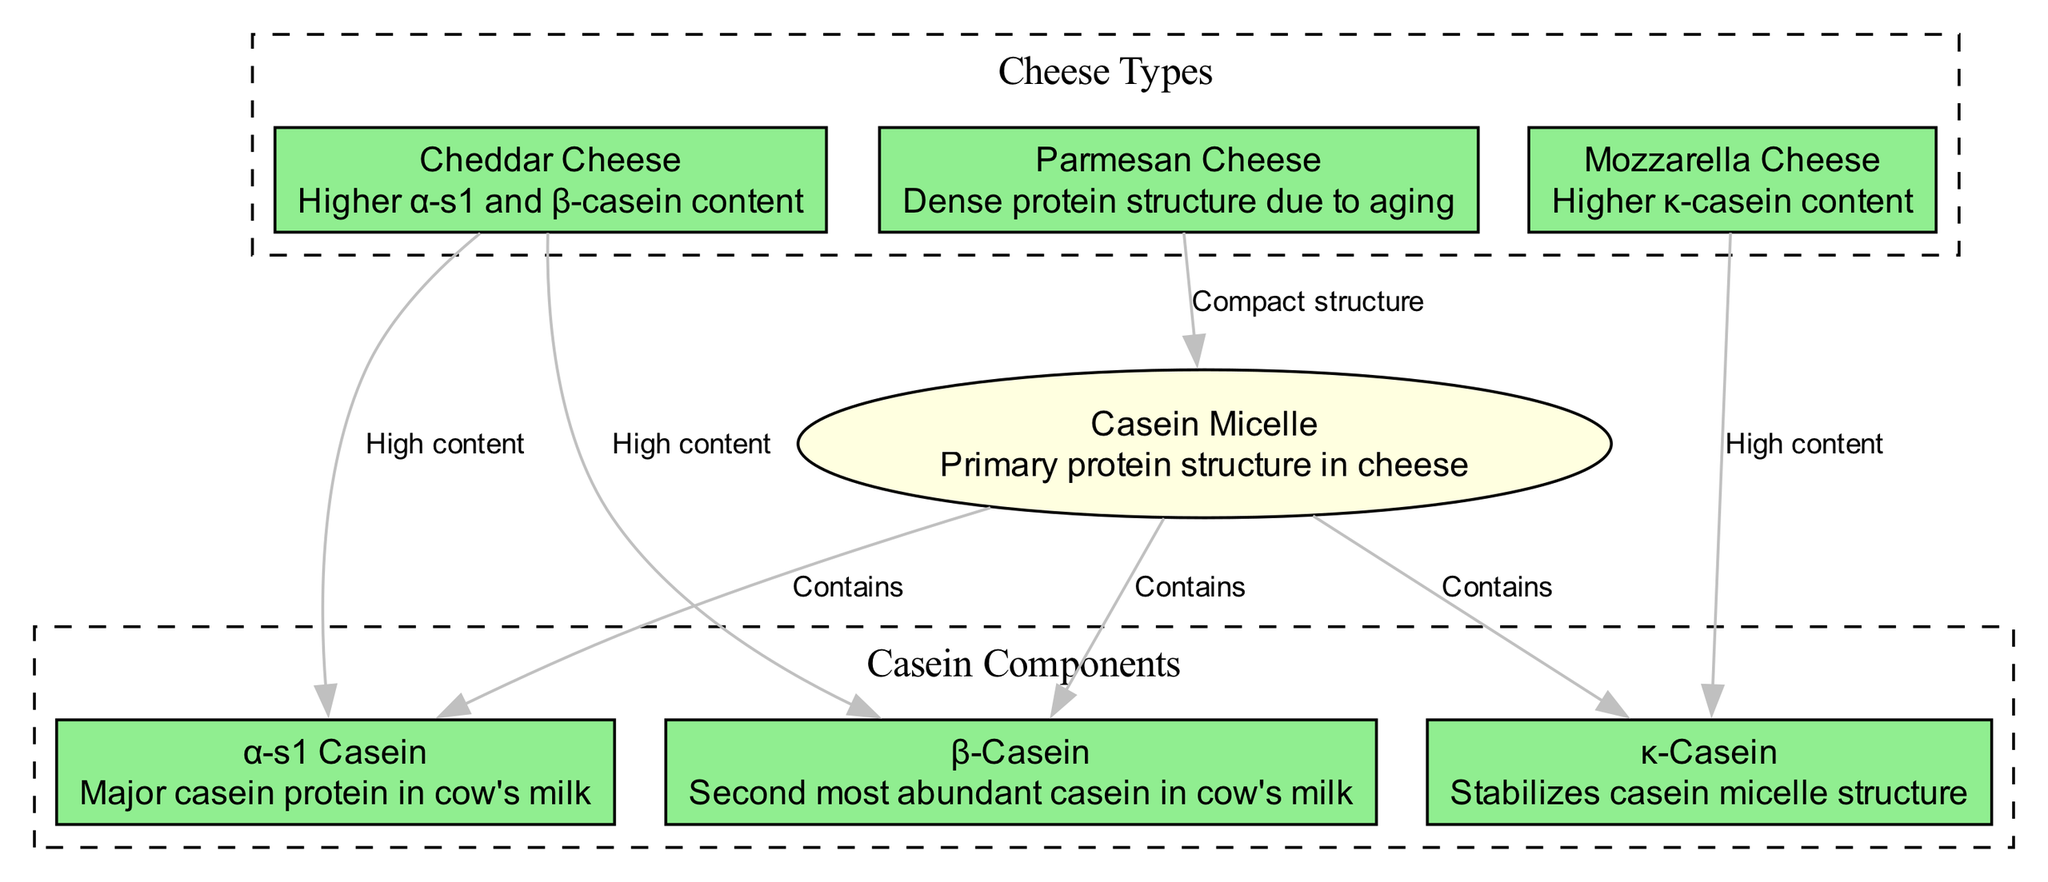What is the primary protein structure in cheese? The diagram shows "Casein Micelle" as the primary protein structure, indicated directly in the label of the relevant node.
Answer: Casein Micelle Which cheese variety is represented as having a high content of both α-s1 and β-casein? By examining the edges connected to the 'cheddar' node, we can see it is labeled with "High content" for both α-s1 Casein and β-Casein.
Answer: Cheddar Cheese How many types of cheese are mentioned in the diagram? The 'Cheese Types' subgraph includes three nodes: Cheddar, Mozzarella, and Parmesan, confirming there are three cheese types shown in the diagram.
Answer: Three Which casein is specifically noted for stabilizing casein micelle structure? The node labeled "κ-Casein" directly states that it stabilizes the casein micelle structure, as indicated by its description.
Answer: κ-Casein What is unique about Parmesan cheese’s protein structure according to the diagram? The diagram states that Parmesan cheese has a "Compact structure" which suggests a unique characteristic, specifically pertaining to its density and aging process.
Answer: Compact structure Which cheese has a higher content of κ-casein? The edges originating from the 'mozzarella' node highlight it has a "High content" of κ-casein, directly answering the question.
Answer: Mozzarella Cheese What is the relationship between casein micelle and β-casein in the diagram? A directed edge connects the 'casein_micelle' node to the 'beta_casein' node with the label "Contains," indicating that β-casein is part of the composition of casein micelles.
Answer: Contains In total, how many casein proteins are identified in the diagram? The diagram lists three casein proteins: α-s1 Casein, β-Casein, and κ-Casein, thus providing a total of three distinct casein proteins shown.
Answer: Three Which type of cheese has a higher content of caseins overall? The relationships shown under both Cheddar and Mozzarella indicate their respective contents, but Cheddar's mention of "High content" for both α-s1 and β-casein suggests it has a higher content overall.
Answer: Cheddar Cheese 